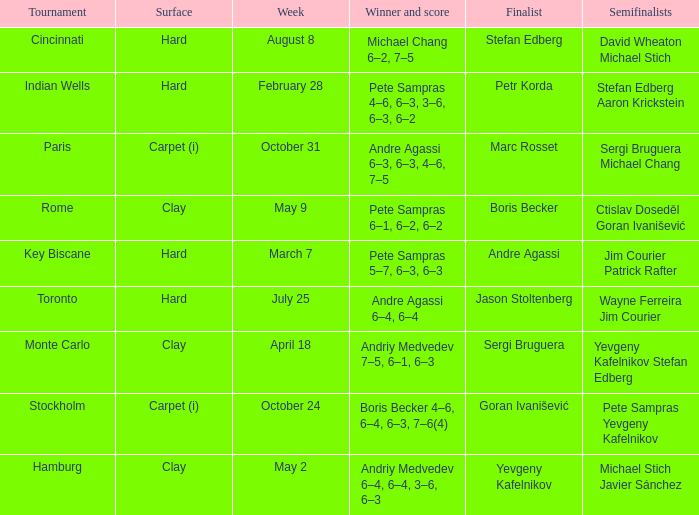Who was the semifinalist for the key biscane tournament? Jim Courier Patrick Rafter. 